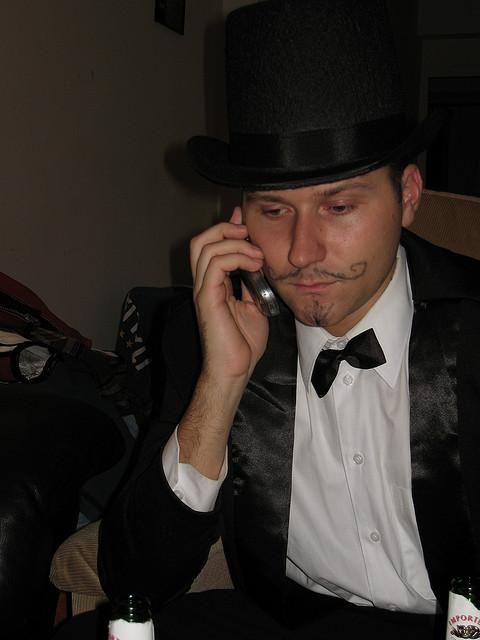What kind of phone is he using? cell phone 